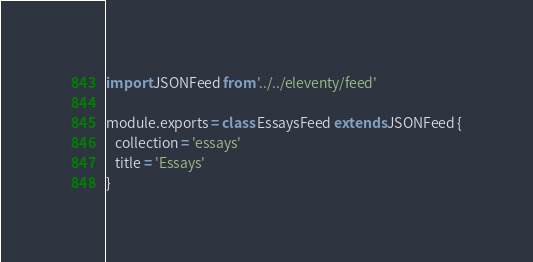Convert code to text. <code><loc_0><loc_0><loc_500><loc_500><_JavaScript_>import JSONFeed from '../../eleventy/feed'

module.exports = class EssaysFeed extends JSONFeed {
   collection = 'essays'
   title = 'Essays'
}
</code> 